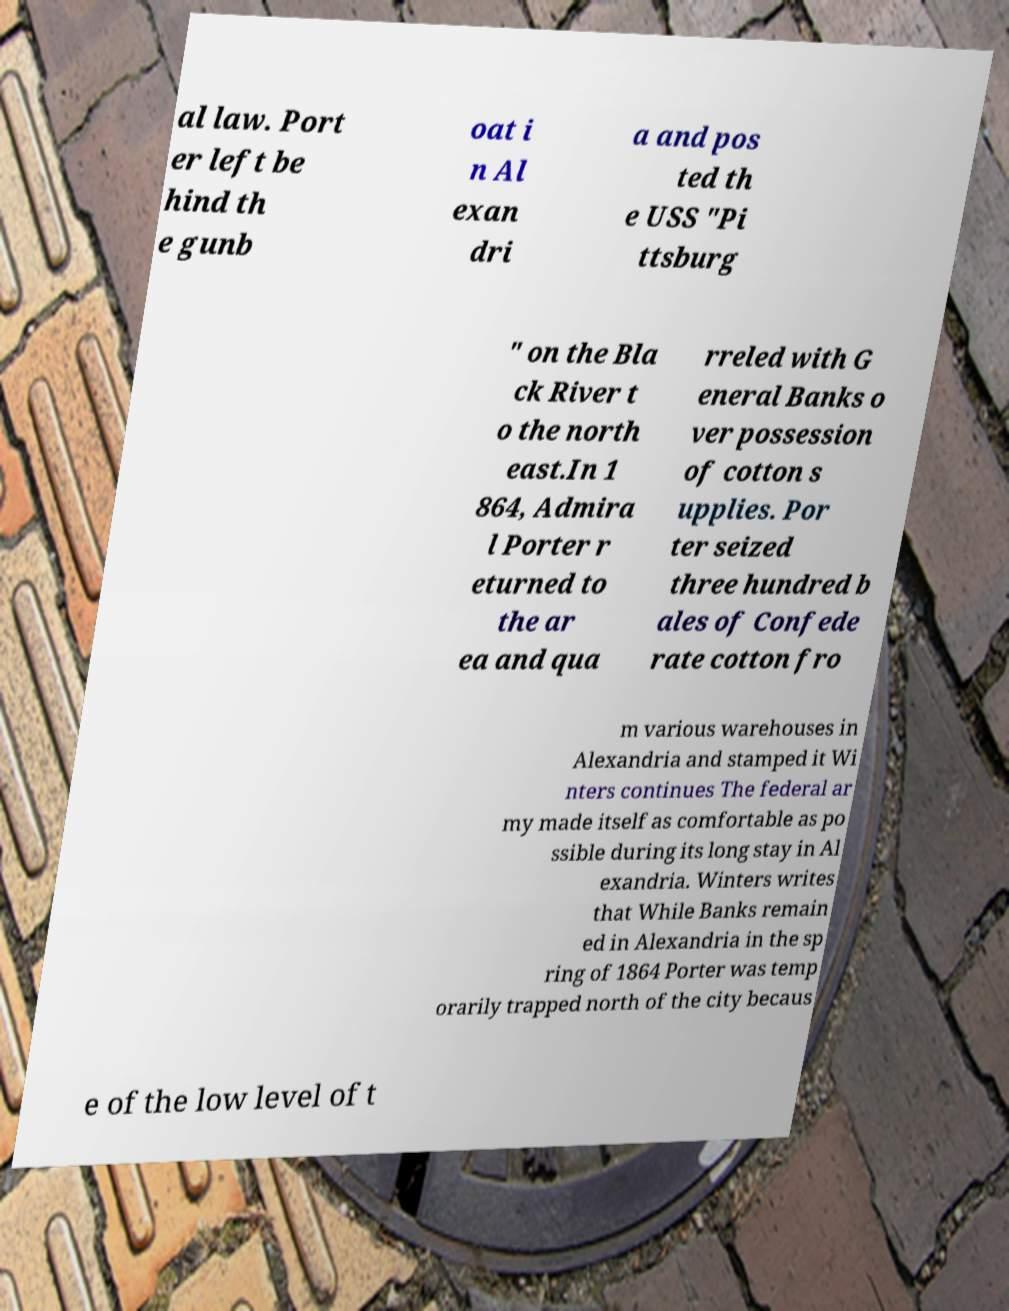Can you accurately transcribe the text from the provided image for me? al law. Port er left be hind th e gunb oat i n Al exan dri a and pos ted th e USS "Pi ttsburg " on the Bla ck River t o the north east.In 1 864, Admira l Porter r eturned to the ar ea and qua rreled with G eneral Banks o ver possession of cotton s upplies. Por ter seized three hundred b ales of Confede rate cotton fro m various warehouses in Alexandria and stamped it Wi nters continues The federal ar my made itself as comfortable as po ssible during its long stay in Al exandria. Winters writes that While Banks remain ed in Alexandria in the sp ring of 1864 Porter was temp orarily trapped north of the city becaus e of the low level of t 